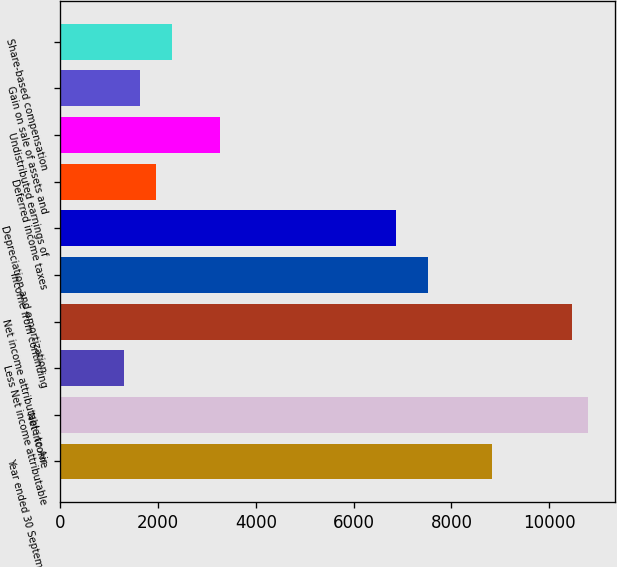Convert chart to OTSL. <chart><loc_0><loc_0><loc_500><loc_500><bar_chart><fcel>Year ended 30 September<fcel>Net income<fcel>Less Net income attributable<fcel>Net income attributable to Air<fcel>Income from continuing<fcel>Depreciation and amortization<fcel>Deferred income taxes<fcel>Undistributed earnings of<fcel>Gain on sale of assets and<fcel>Share-based compensation<nl><fcel>8832.94<fcel>10795.1<fcel>1311.48<fcel>10468<fcel>7524.86<fcel>6870.82<fcel>1965.52<fcel>3273.6<fcel>1638.5<fcel>2292.54<nl></chart> 